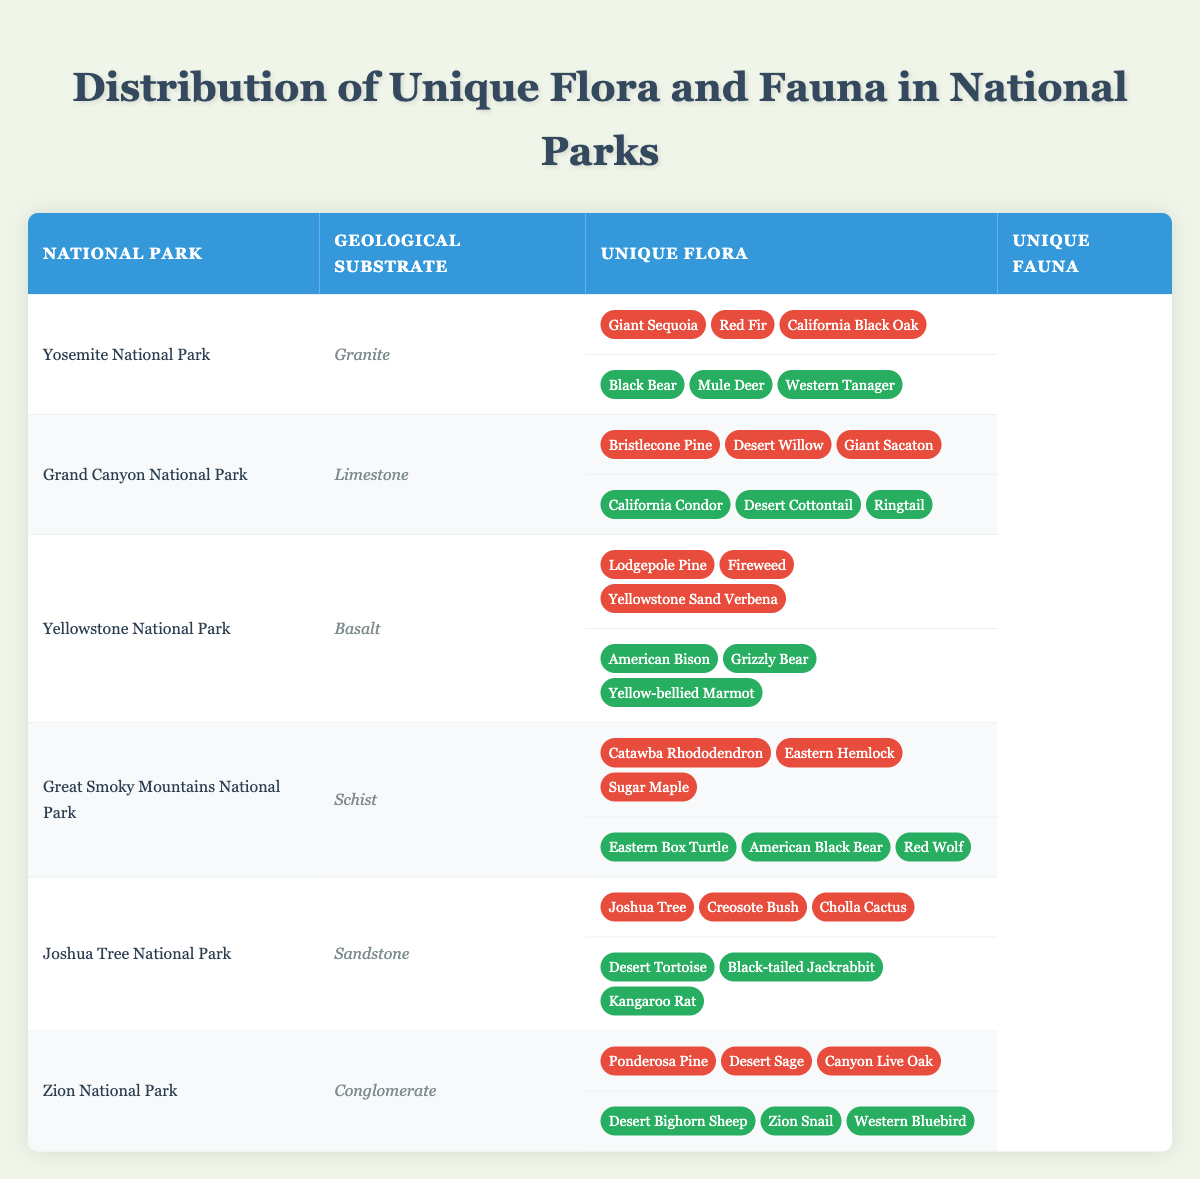What unique flora can be found in Yosemite National Park? The table lists the unique flora for Yosemite National Park, which includes Giant Sequoia, Red Fir, and California Black Oak. I can find this information directly from the corresponding row in the table.
Answer: Giant Sequoia, Red Fir, California Black Oak Which national park has limestone as its geological substrate type? By checking the geological substrate type column in the table, I find that Grand Canyon National Park is the one that lists limestone as its geological substrate.
Answer: Grand Canyon National Park How many unique fauna are reported in Joshua Tree National Park? The unique fauna listed for Joshua Tree National Park includes Desert Tortoise, Black-tailed Jackrabbit, and Kangaroo Rat. Counting these, there are three unique fauna.
Answer: 3 Is it true that the Great Smoky Mountains National Park has a Black Bear among its unique fauna? Looking at the unique fauna listed for Great Smoky Mountains National Park, Black Bear is mentioned. Thus, this statement is true based on the information provided.
Answer: Yes What is the difference in unique flora count between Yellowstone National Park and Yosemite National Park? Both national parks have a total of three unique flora species listed: Lodgepole Pine, Fireweed, Yellowstone Sand Verbena for Yellowstone, and Giant Sequoia, Red Fir, California Black Oak for Yosemite. The difference is therefore 3 - 3 = 0, meaning they have the same count.
Answer: 0 What is the common unique fauna between Grand Canyon National Park and Yellowstone National Park? By examining the unique fauna listed for both national parks, I check each corresponding fauna and find that they do not share any species, as California Condor, Desert Cottontail, and Ringtail in Grand Canyon differ entirely from American Bison, Grizzly Bear, and Yellow-bellied Marmot in Yellowstone.
Answer: None Which geological substrate type is associated with the largest number of unique flora? Counting the unique flora species listed, all parks have three species. As none have more than three, it suggests that there is no geological substrate type that boasts a larger number of unique flora based on the provided data.
Answer: None What are the unique fauna found in Zion National Park? From the table, the unique fauna mentioned for Zion National Park includes Desert Bighorn Sheep, Zion Snail, and Western Bluebird. This information can be directly retrieved from the respective row.
Answer: Desert Bighorn Sheep, Zion Snail, Western Bluebird 